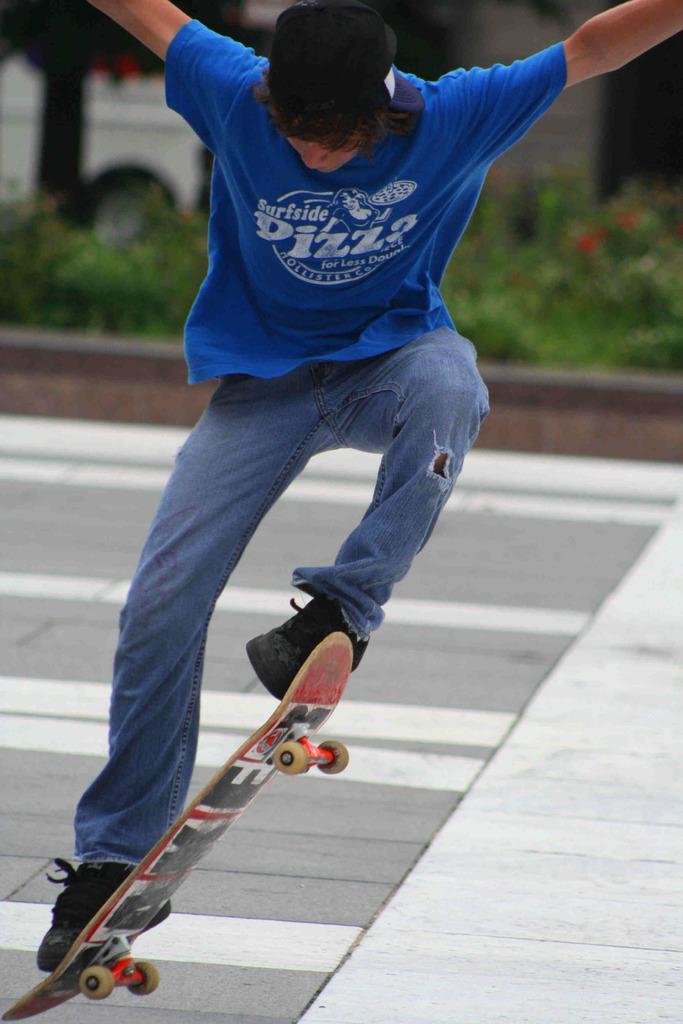In one or two sentences, can you explain what this image depicts? In this picture we can see a man skating on a skateboard, in the background there are some plants, we can see a tree here. 